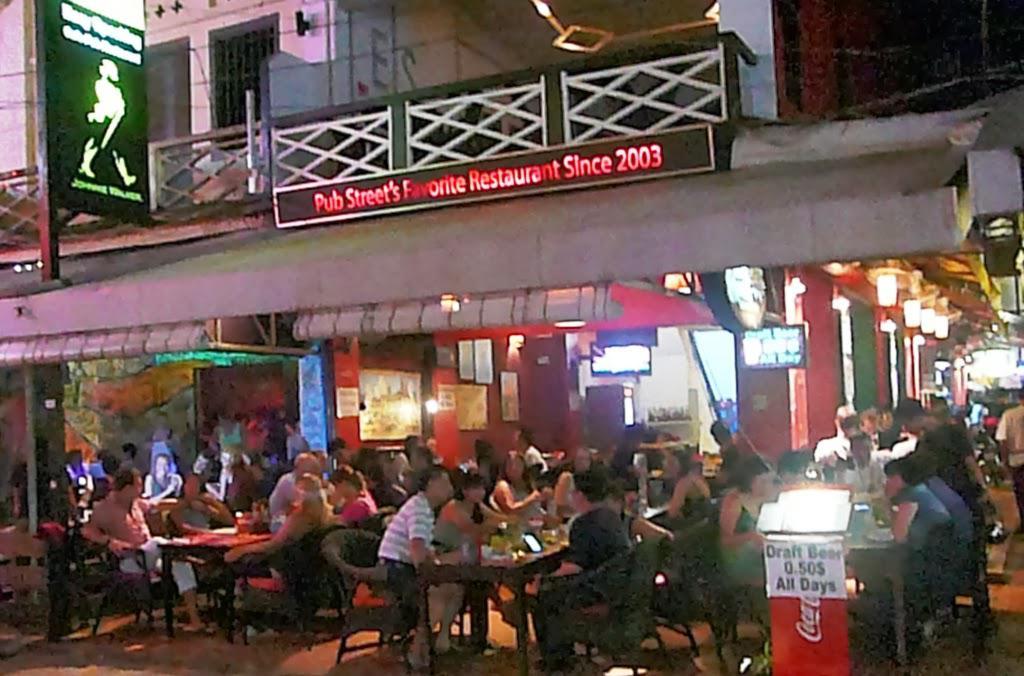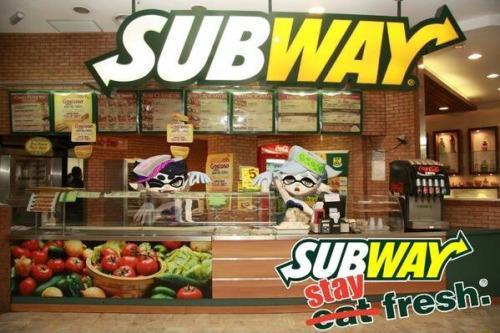The first image is the image on the left, the second image is the image on the right. Examine the images to the left and right. Is the description "One of these shops has a visible coke machine in it." accurate? Answer yes or no. Yes. 